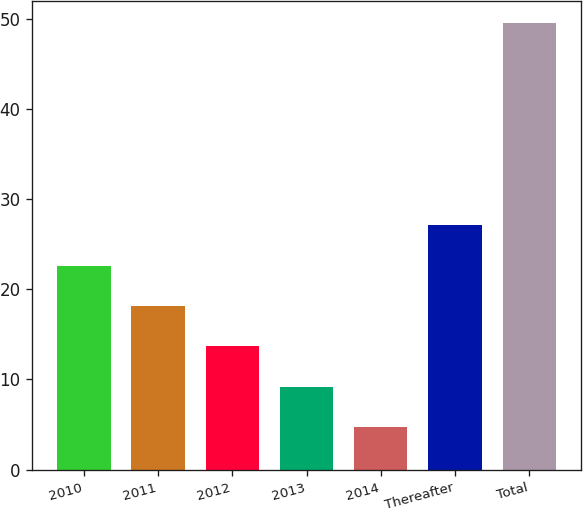Convert chart to OTSL. <chart><loc_0><loc_0><loc_500><loc_500><bar_chart><fcel>2010<fcel>2011<fcel>2012<fcel>2013<fcel>2014<fcel>Thereafter<fcel>Total<nl><fcel>22.62<fcel>18.14<fcel>13.66<fcel>9.18<fcel>4.7<fcel>27.1<fcel>49.5<nl></chart> 